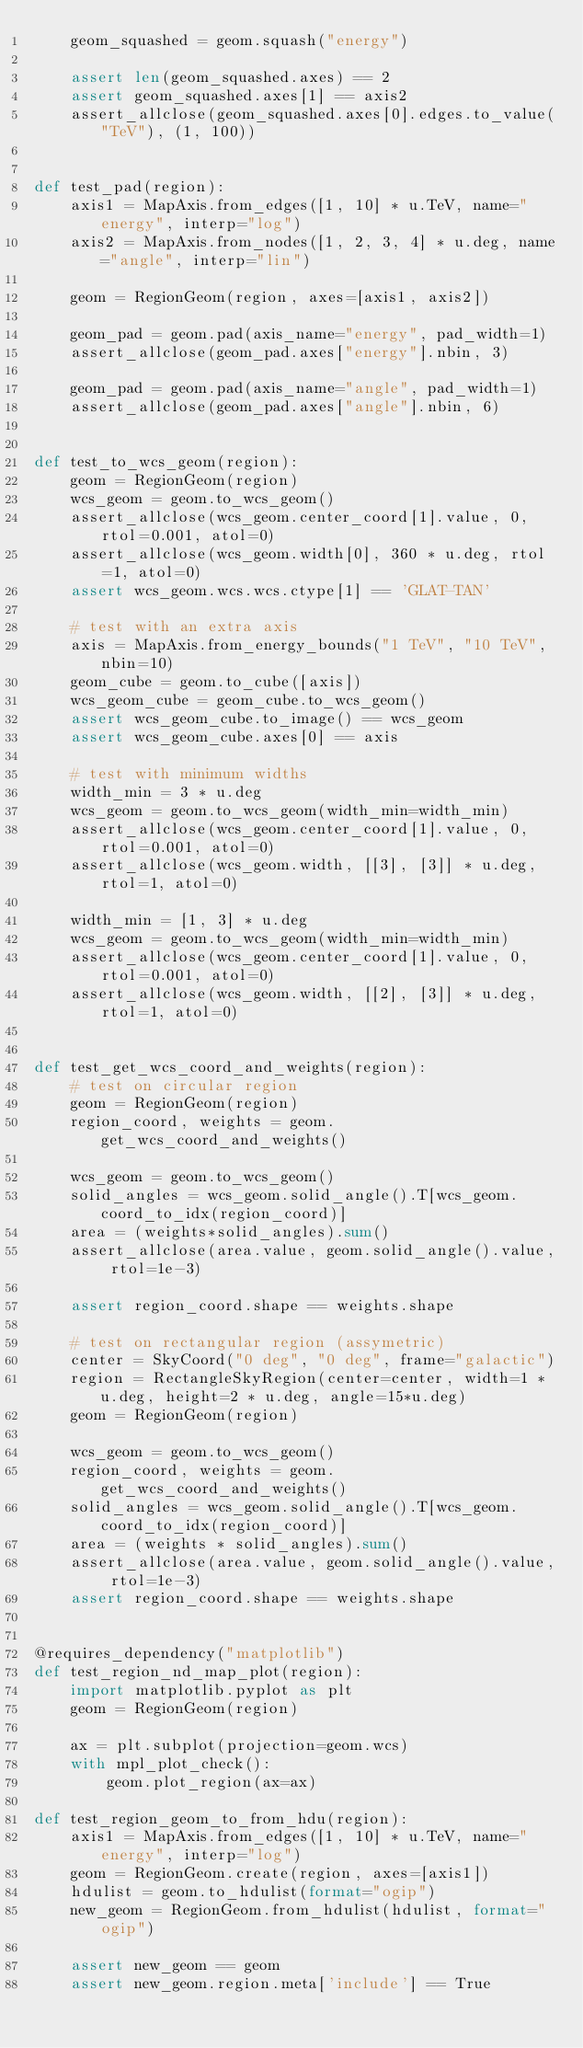<code> <loc_0><loc_0><loc_500><loc_500><_Python_>    geom_squashed = geom.squash("energy")

    assert len(geom_squashed.axes) == 2
    assert geom_squashed.axes[1] == axis2
    assert_allclose(geom_squashed.axes[0].edges.to_value("TeV"), (1, 100))


def test_pad(region):
    axis1 = MapAxis.from_edges([1, 10] * u.TeV, name="energy", interp="log")
    axis2 = MapAxis.from_nodes([1, 2, 3, 4] * u.deg, name="angle", interp="lin")

    geom = RegionGeom(region, axes=[axis1, axis2])

    geom_pad = geom.pad(axis_name="energy", pad_width=1)
    assert_allclose(geom_pad.axes["energy"].nbin, 3)

    geom_pad = geom.pad(axis_name="angle", pad_width=1)
    assert_allclose(geom_pad.axes["angle"].nbin, 6)


def test_to_wcs_geom(region):
    geom = RegionGeom(region)
    wcs_geom = geom.to_wcs_geom()
    assert_allclose(wcs_geom.center_coord[1].value, 0, rtol=0.001, atol=0)
    assert_allclose(wcs_geom.width[0], 360 * u.deg, rtol=1, atol=0)
    assert wcs_geom.wcs.wcs.ctype[1] == 'GLAT-TAN'

    # test with an extra axis
    axis = MapAxis.from_energy_bounds("1 TeV", "10 TeV", nbin=10)
    geom_cube = geom.to_cube([axis])
    wcs_geom_cube = geom_cube.to_wcs_geom()
    assert wcs_geom_cube.to_image() == wcs_geom
    assert wcs_geom_cube.axes[0] == axis

    # test with minimum widths
    width_min = 3 * u.deg
    wcs_geom = geom.to_wcs_geom(width_min=width_min)
    assert_allclose(wcs_geom.center_coord[1].value, 0, rtol=0.001, atol=0)
    assert_allclose(wcs_geom.width, [[3], [3]] * u.deg, rtol=1, atol=0)

    width_min = [1, 3] * u.deg
    wcs_geom = geom.to_wcs_geom(width_min=width_min)
    assert_allclose(wcs_geom.center_coord[1].value, 0, rtol=0.001, atol=0)
    assert_allclose(wcs_geom.width, [[2], [3]] * u.deg, rtol=1, atol=0)


def test_get_wcs_coord_and_weights(region):
    # test on circular region
    geom = RegionGeom(region)
    region_coord, weights = geom.get_wcs_coord_and_weights()

    wcs_geom = geom.to_wcs_geom()
    solid_angles = wcs_geom.solid_angle().T[wcs_geom.coord_to_idx(region_coord)]
    area = (weights*solid_angles).sum()
    assert_allclose(area.value, geom.solid_angle().value, rtol=1e-3)

    assert region_coord.shape == weights.shape

    # test on rectangular region (assymetric)
    center = SkyCoord("0 deg", "0 deg", frame="galactic")
    region = RectangleSkyRegion(center=center, width=1 * u.deg, height=2 * u.deg, angle=15*u.deg)
    geom = RegionGeom(region)

    wcs_geom = geom.to_wcs_geom()
    region_coord, weights = geom.get_wcs_coord_and_weights()
    solid_angles = wcs_geom.solid_angle().T[wcs_geom.coord_to_idx(region_coord)]
    area = (weights * solid_angles).sum()
    assert_allclose(area.value, geom.solid_angle().value, rtol=1e-3)
    assert region_coord.shape == weights.shape


@requires_dependency("matplotlib")
def test_region_nd_map_plot(region):
    import matplotlib.pyplot as plt
    geom = RegionGeom(region)

    ax = plt.subplot(projection=geom.wcs)
    with mpl_plot_check():
        geom.plot_region(ax=ax)

def test_region_geom_to_from_hdu(region):
    axis1 = MapAxis.from_edges([1, 10] * u.TeV, name="energy", interp="log")
    geom = RegionGeom.create(region, axes=[axis1])
    hdulist = geom.to_hdulist(format="ogip")
    new_geom = RegionGeom.from_hdulist(hdulist, format="ogip")

    assert new_geom == geom
    assert new_geom.region.meta['include'] == True</code> 